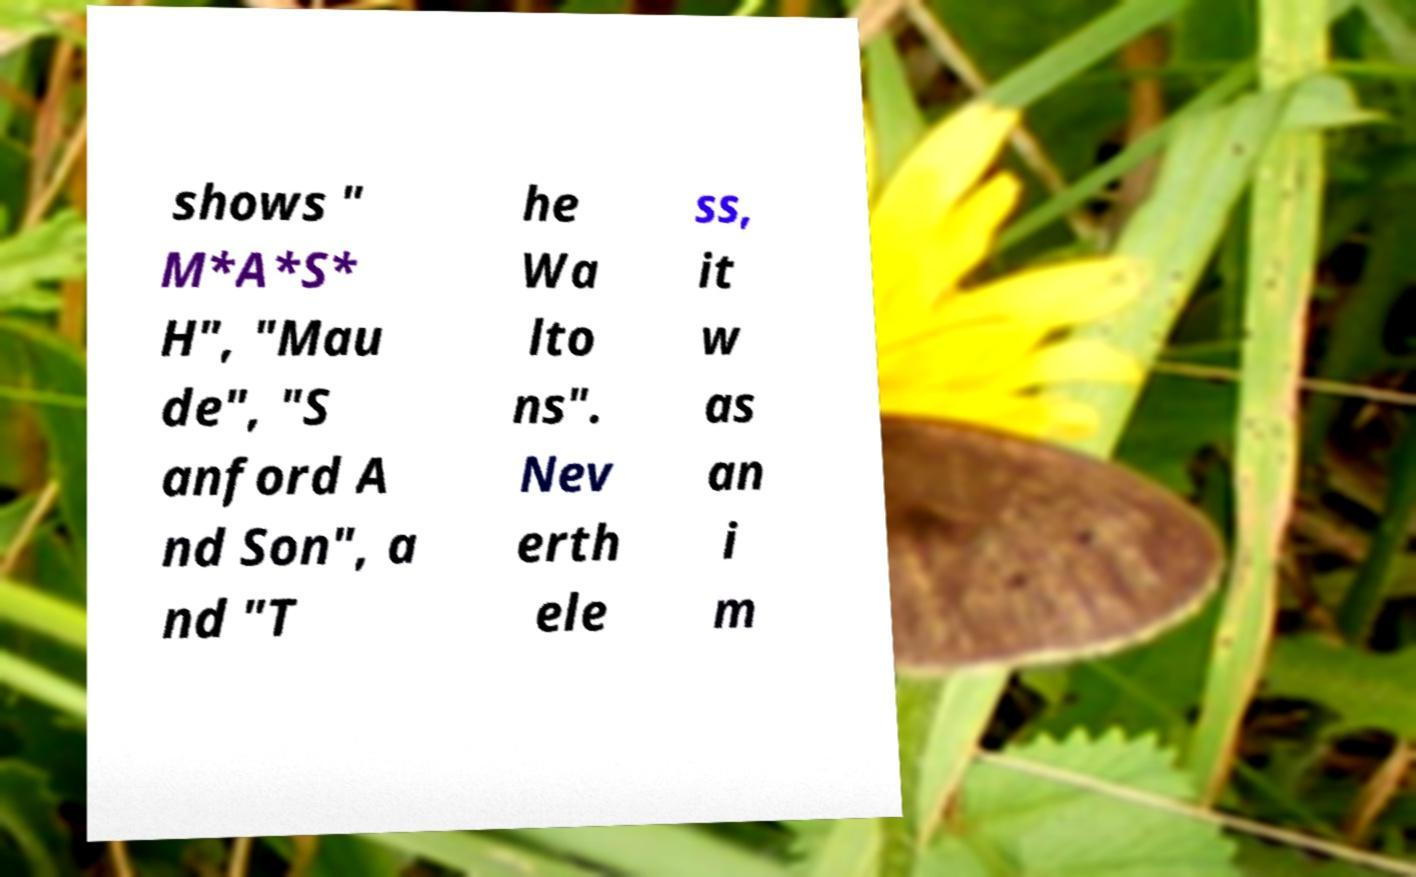Can you read and provide the text displayed in the image?This photo seems to have some interesting text. Can you extract and type it out for me? shows " M*A*S* H", "Mau de", "S anford A nd Son", a nd "T he Wa lto ns". Nev erth ele ss, it w as an i m 